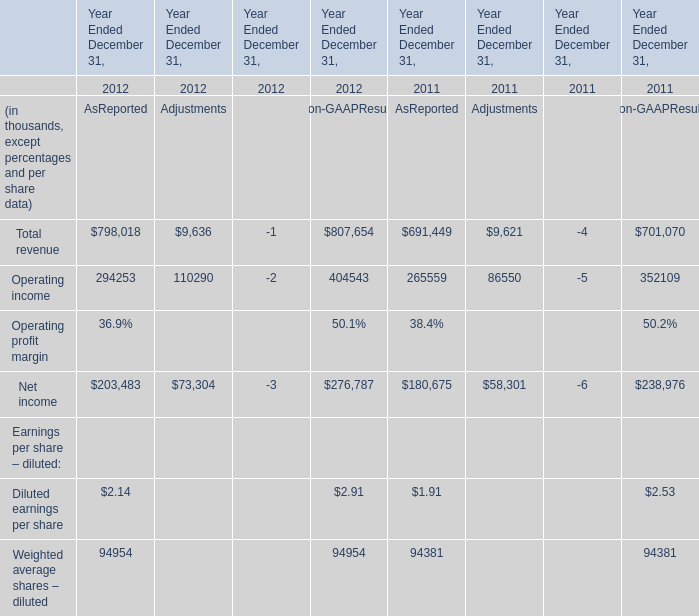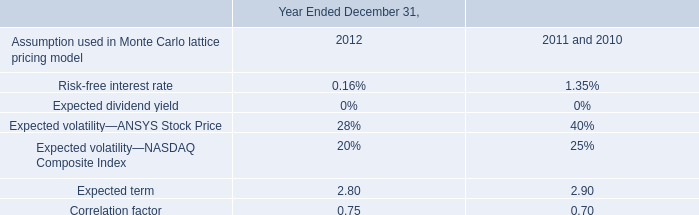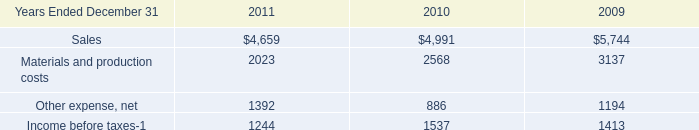What's the average of Net income in 2011 and 2012 for AsReported? (in thousand) 
Computations: ((203483 + 180675) / 2)
Answer: 192079.0. 